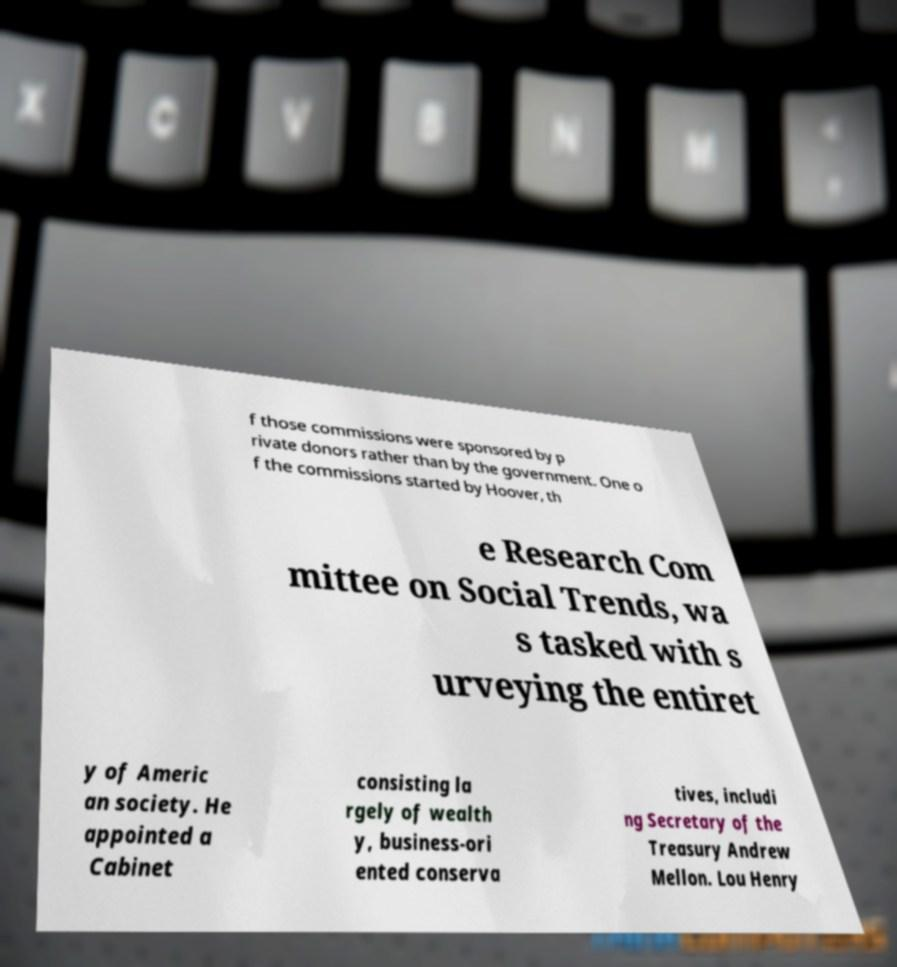Can you accurately transcribe the text from the provided image for me? f those commissions were sponsored by p rivate donors rather than by the government. One o f the commissions started by Hoover, th e Research Com mittee on Social Trends, wa s tasked with s urveying the entiret y of Americ an society. He appointed a Cabinet consisting la rgely of wealth y, business-ori ented conserva tives, includi ng Secretary of the Treasury Andrew Mellon. Lou Henry 